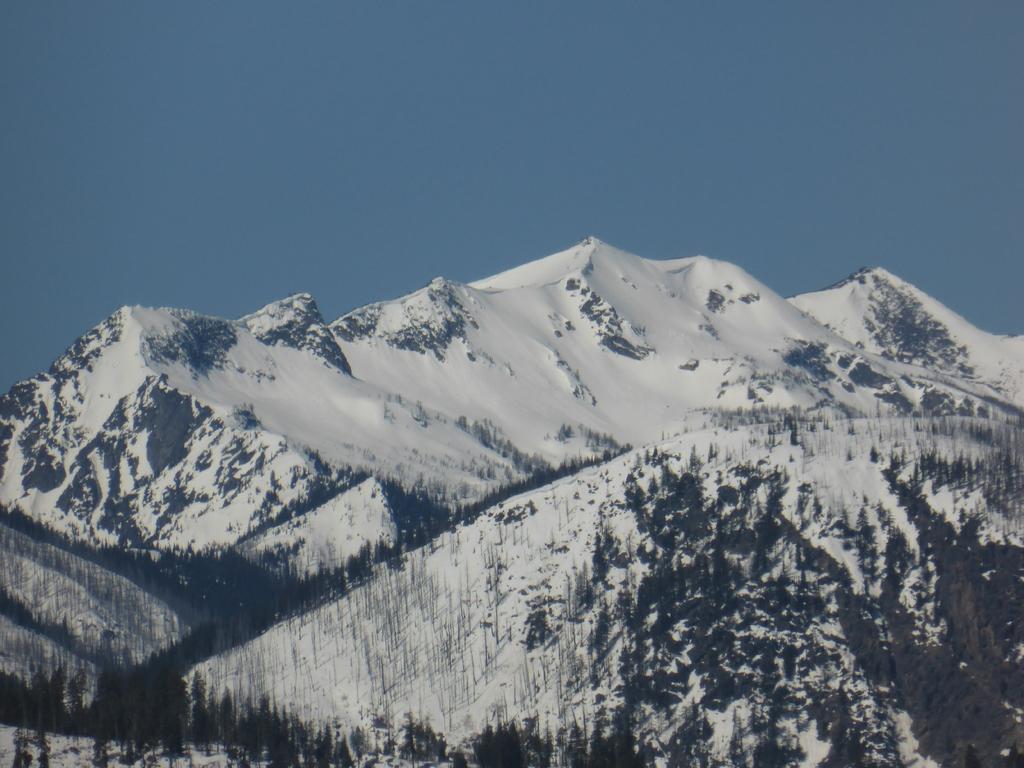Can you describe this image briefly? In this image, we can see mountains and we can see snow on the mountains. At the top we can see the blue sky. 